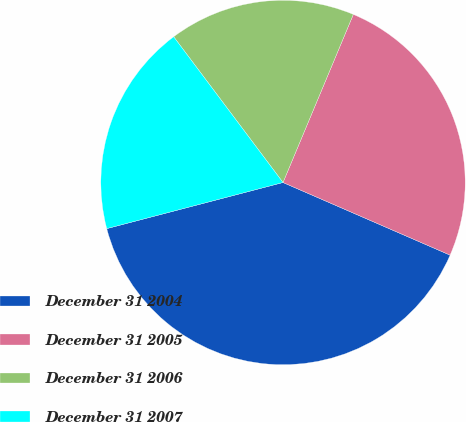Convert chart. <chart><loc_0><loc_0><loc_500><loc_500><pie_chart><fcel>December 31 2004<fcel>December 31 2005<fcel>December 31 2006<fcel>December 31 2007<nl><fcel>39.4%<fcel>25.22%<fcel>16.55%<fcel>18.83%<nl></chart> 